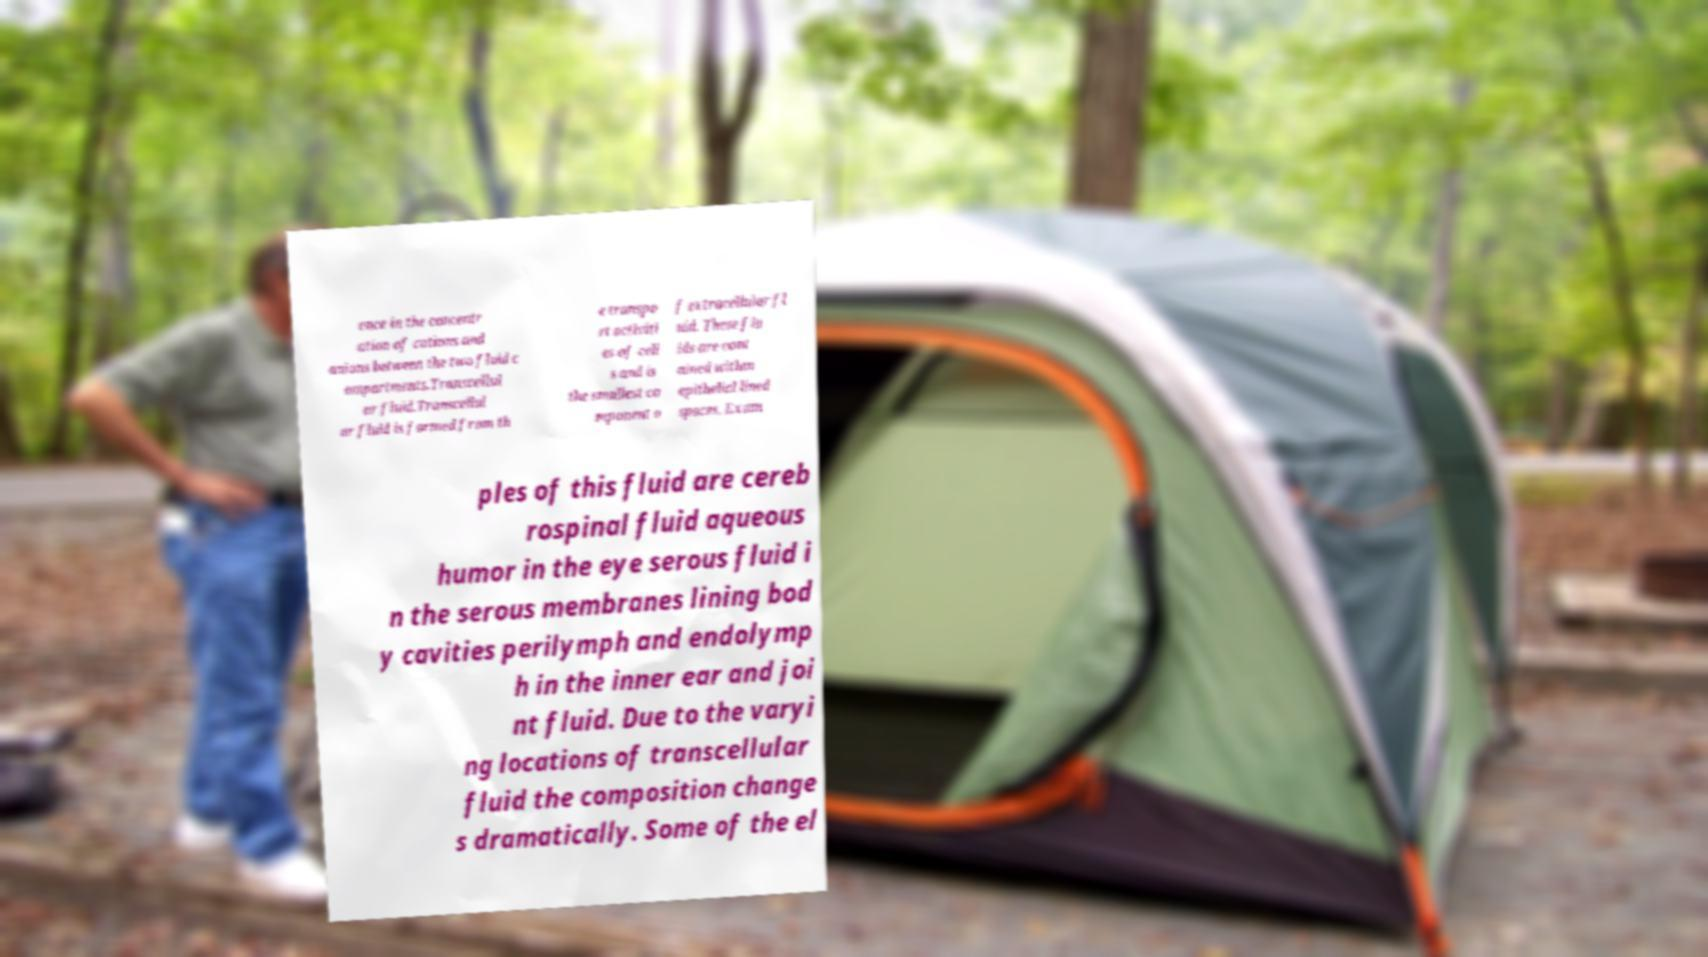Please identify and transcribe the text found in this image. ence in the concentr ation of cations and anions between the two fluid c ompartments.Transcellul ar fluid.Transcellul ar fluid is formed from th e transpo rt activiti es of cell s and is the smallest co mponent o f extracellular fl uid. These flu ids are cont ained within epithelial lined spaces. Exam ples of this fluid are cereb rospinal fluid aqueous humor in the eye serous fluid i n the serous membranes lining bod y cavities perilymph and endolymp h in the inner ear and joi nt fluid. Due to the varyi ng locations of transcellular fluid the composition change s dramatically. Some of the el 